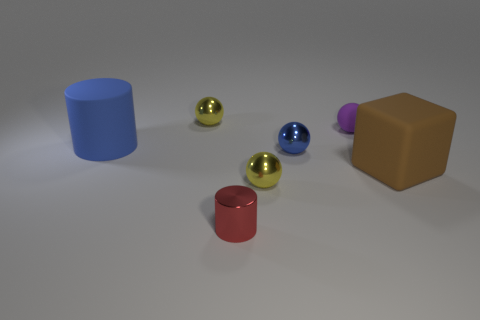Add 1 blue rubber objects. How many objects exist? 8 Subtract all cylinders. How many objects are left? 5 Subtract all big cyan metal blocks. Subtract all blue balls. How many objects are left? 6 Add 7 blue matte cylinders. How many blue matte cylinders are left? 8 Add 7 small cyan metallic things. How many small cyan metallic things exist? 7 Subtract 0 cyan balls. How many objects are left? 7 